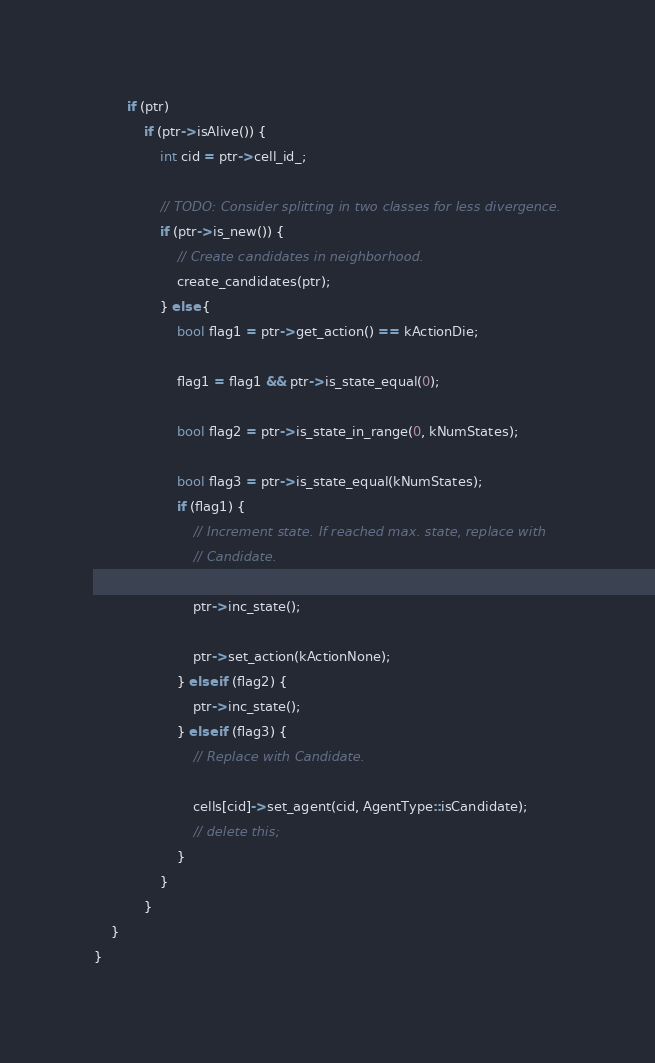Convert code to text. <code><loc_0><loc_0><loc_500><loc_500><_Cuda_>        if (ptr)
            if (ptr->isAlive()) {
                int cid = ptr->cell_id_;

                // TODO: Consider splitting in two classes for less divergence.
                if (ptr->is_new()) {
                    // Create candidates in neighborhood.
                    create_candidates(ptr);
                } else {
                    bool flag1 = ptr->get_action() == kActionDie;

                    flag1 = flag1 && ptr->is_state_equal(0);

                    bool flag2 = ptr->is_state_in_range(0, kNumStates);

                    bool flag3 = ptr->is_state_equal(kNumStates);
                    if (flag1) {
                        // Increment state. If reached max. state, replace with
                        // Candidate.

                        ptr->inc_state();

                        ptr->set_action(kActionNone);
                    } else if (flag2) {
                        ptr->inc_state();
                    } else if (flag3) {
                        // Replace with Candidate.

                        cells[cid]->set_agent(cid, AgentType::isCandidate);
                        // delete this;
                    }
                }
            }
    }
}
</code> 